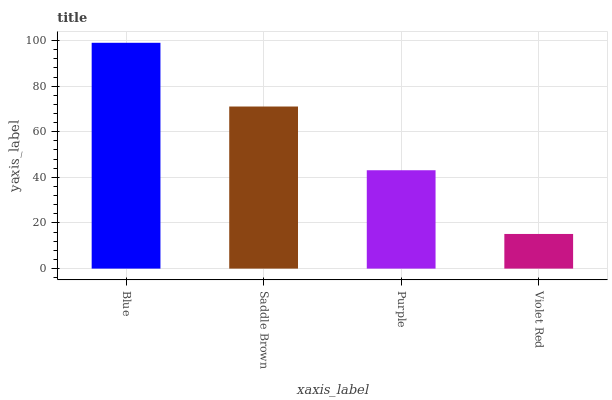Is Saddle Brown the minimum?
Answer yes or no. No. Is Saddle Brown the maximum?
Answer yes or no. No. Is Blue greater than Saddle Brown?
Answer yes or no. Yes. Is Saddle Brown less than Blue?
Answer yes or no. Yes. Is Saddle Brown greater than Blue?
Answer yes or no. No. Is Blue less than Saddle Brown?
Answer yes or no. No. Is Saddle Brown the high median?
Answer yes or no. Yes. Is Purple the low median?
Answer yes or no. Yes. Is Purple the high median?
Answer yes or no. No. Is Blue the low median?
Answer yes or no. No. 